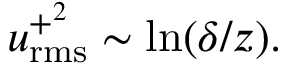Convert formula to latex. <formula><loc_0><loc_0><loc_500><loc_500>u _ { r m s } ^ { + ^ { 2 } } \sim \ln ( \delta / z ) .</formula> 